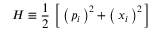<formula> <loc_0><loc_0><loc_500><loc_500>H \equiv \frac { 1 } { 2 } \, \left [ \, \left ( \, p _ { i } \, \right ) ^ { 2 } + \left ( \, x _ { i } \, \right ) ^ { 2 } \, \right ]</formula> 